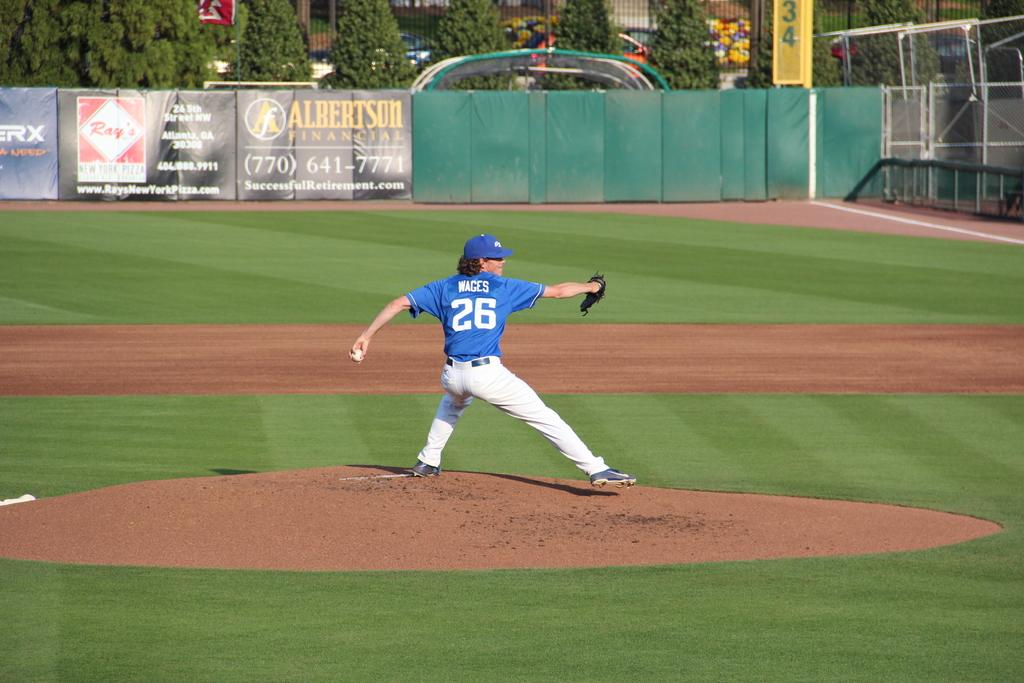Provide a one-sentence caption for the provided image. Pitcher number 26, Wages, winds up to throw a pitch during the baseball game. 